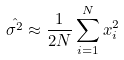<formula> <loc_0><loc_0><loc_500><loc_500>\hat { \sigma ^ { 2 } } \approx \frac { 1 } { 2 N } \sum _ { i = 1 } ^ { N } x _ { i } ^ { 2 }</formula> 